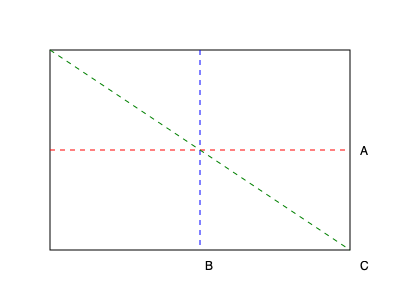As you prepare to design your book display for an American literature fair, you're considering a unique rectangular prism-shaped bookshelf. The diagram shows three different cutting planes (A, B, and C) intersecting the prism. Which cutting plane would result in a cross-section that's neither a rectangle nor a square? Let's analyze each cutting plane:

1. Plane A (red dashed line):
   - This plane is parallel to the base of the prism.
   - A cut along this plane would result in a rectangle, as it's parallel to the rectangular face.

2. Plane B (blue dashed line):
   - This plane is perpendicular to the base and parallel to one side of the prism.
   - A cut along this plane would also result in a rectangle, as it's parallel to one of the rectangular faces.

3. Plane C (green dashed line):
   - This plane intersects the prism diagonally from one corner to the opposite corner.
   - It is not parallel to any face of the rectangular prism.
   - A cut along this plane would result in a polygon that is neither a rectangle nor a square.

The shape resulting from Plane C would be a polygon with six sides (hexagon), as it intersects all faces of the rectangular prism at an angle.
Answer: C 